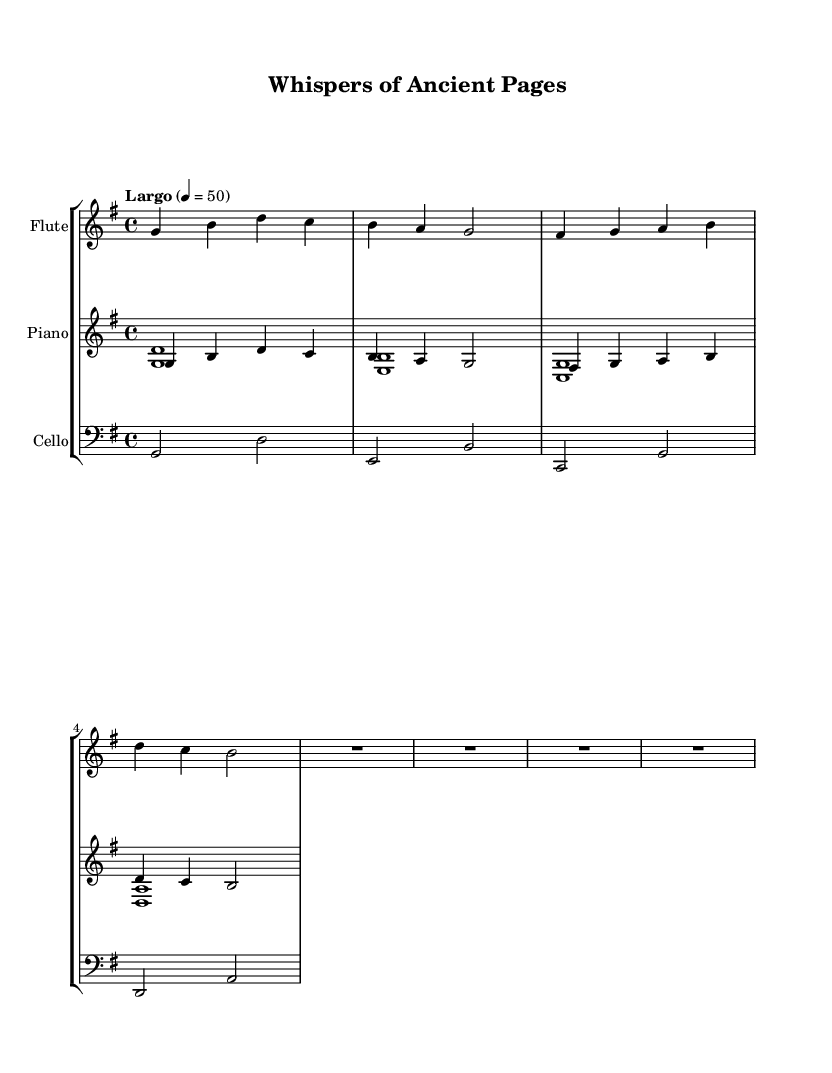What is the key signature of this music? The key signature is G major, which has one sharp (F#). This can be deduced from the global section in the code where it indicates the key as G.
Answer: G major What is the time signature of the piece? The time signature is 4/4, as indicated in the global section of the code. This means there are four beats per measure, and the quarter note gets one beat.
Answer: 4/4 What is the tempo marking for this music? The tempo marking is "Largo", which is specified in the global section. This indicates a slow pace for the piece.
Answer: Largo How many measures are present in the flute part? There are four measures in the flute part, as counted from the music notation provided in the flute section of the code.
Answer: 4 What type of musical ensemble is this piece written for? The piece is written for a trio consisting of flute, piano, and cello, as the score includes these three distinct instruments in their respective staffs.
Answer: Trio Which instrument plays the lowest notes in this music? The cello plays the lowest notes, indicated by the use of the bass clef in its staff, which typically represents lower pitches compared to the other instruments.
Answer: Cello What is the overall character of the piece based on its musical elements? The overall character is meditative, as exhibited by the slow tempo, soft instrumental tones, and melodic lines that blend harmoniously with nature sounds reference, creating a calming effect.
Answer: Meditative 